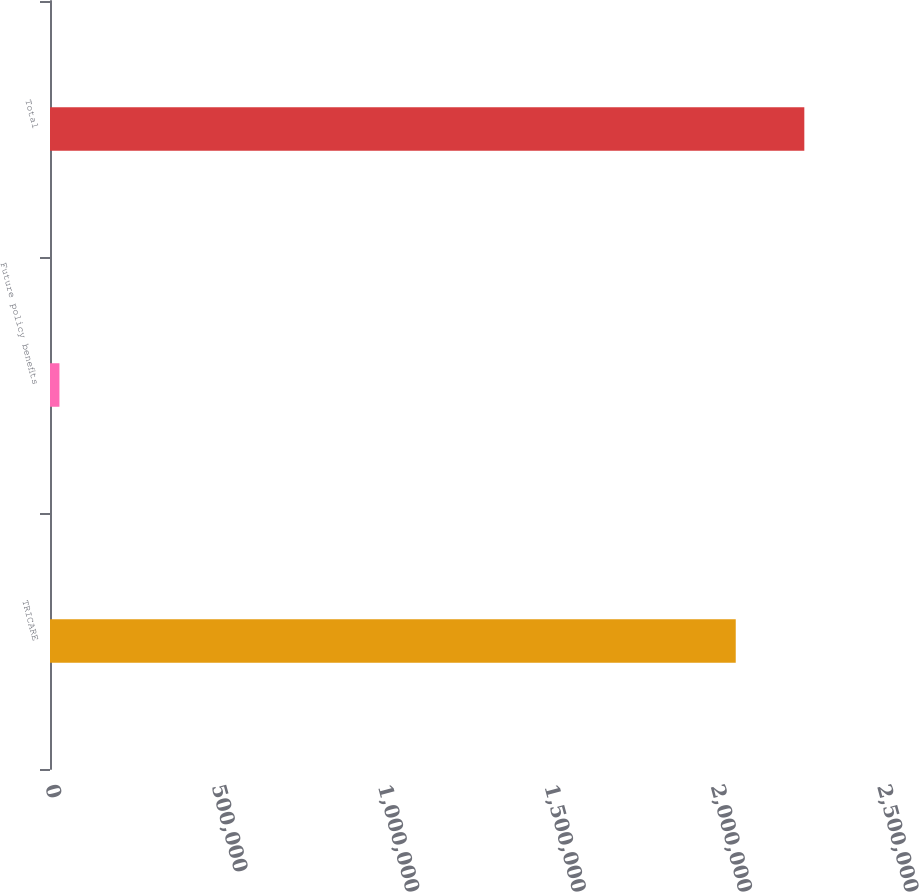<chart> <loc_0><loc_0><loc_500><loc_500><bar_chart><fcel>TRICARE<fcel>Future policy benefits<fcel>Total<nl><fcel>2.06053e+06<fcel>28375<fcel>2.26658e+06<nl></chart> 